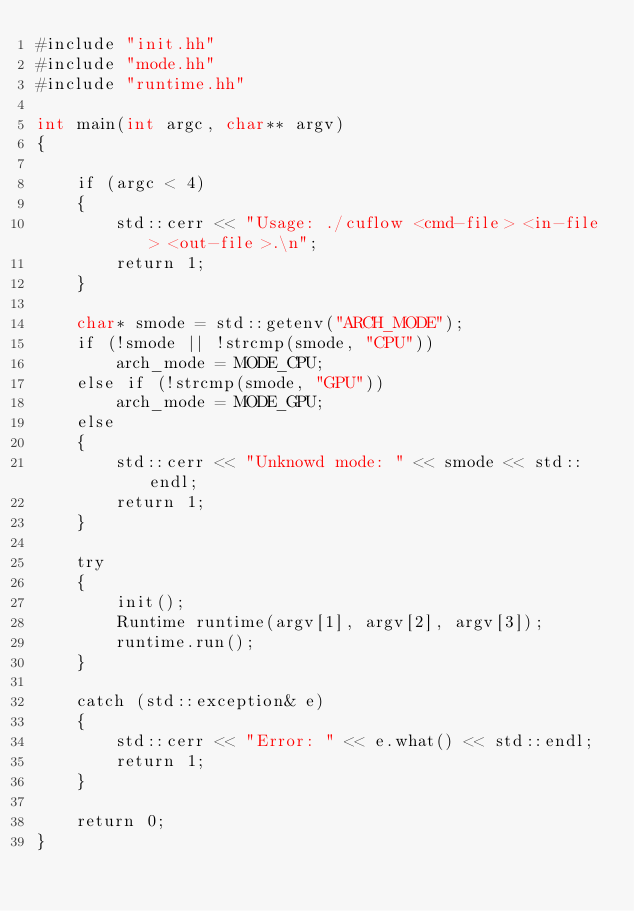<code> <loc_0><loc_0><loc_500><loc_500><_Cuda_>#include "init.hh"
#include "mode.hh"
#include "runtime.hh"

int main(int argc, char** argv)
{
    
    if (argc < 4)
    {
        std::cerr << "Usage: ./cuflow <cmd-file> <in-file> <out-file>.\n";
        return 1;
    }

    char* smode = std::getenv("ARCH_MODE");
    if (!smode || !strcmp(smode, "CPU"))
        arch_mode = MODE_CPU;
    else if (!strcmp(smode, "GPU"))
        arch_mode = MODE_GPU;
    else
    {
        std::cerr << "Unknowd mode: " << smode << std::endl;
        return 1;
    }

    try
    {
        init();
        Runtime runtime(argv[1], argv[2], argv[3]);
        runtime.run();
    }

    catch (std::exception& e)
    {
        std::cerr << "Error: " << e.what() << std::endl;
        return 1;
    }
    
    return 0;
}
</code> 